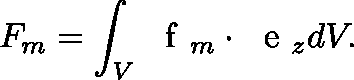Convert formula to latex. <formula><loc_0><loc_0><loc_500><loc_500>F _ { m } = \int _ { V } \boldmath f _ { m } \cdot \boldmath e _ { z } d V .</formula> 